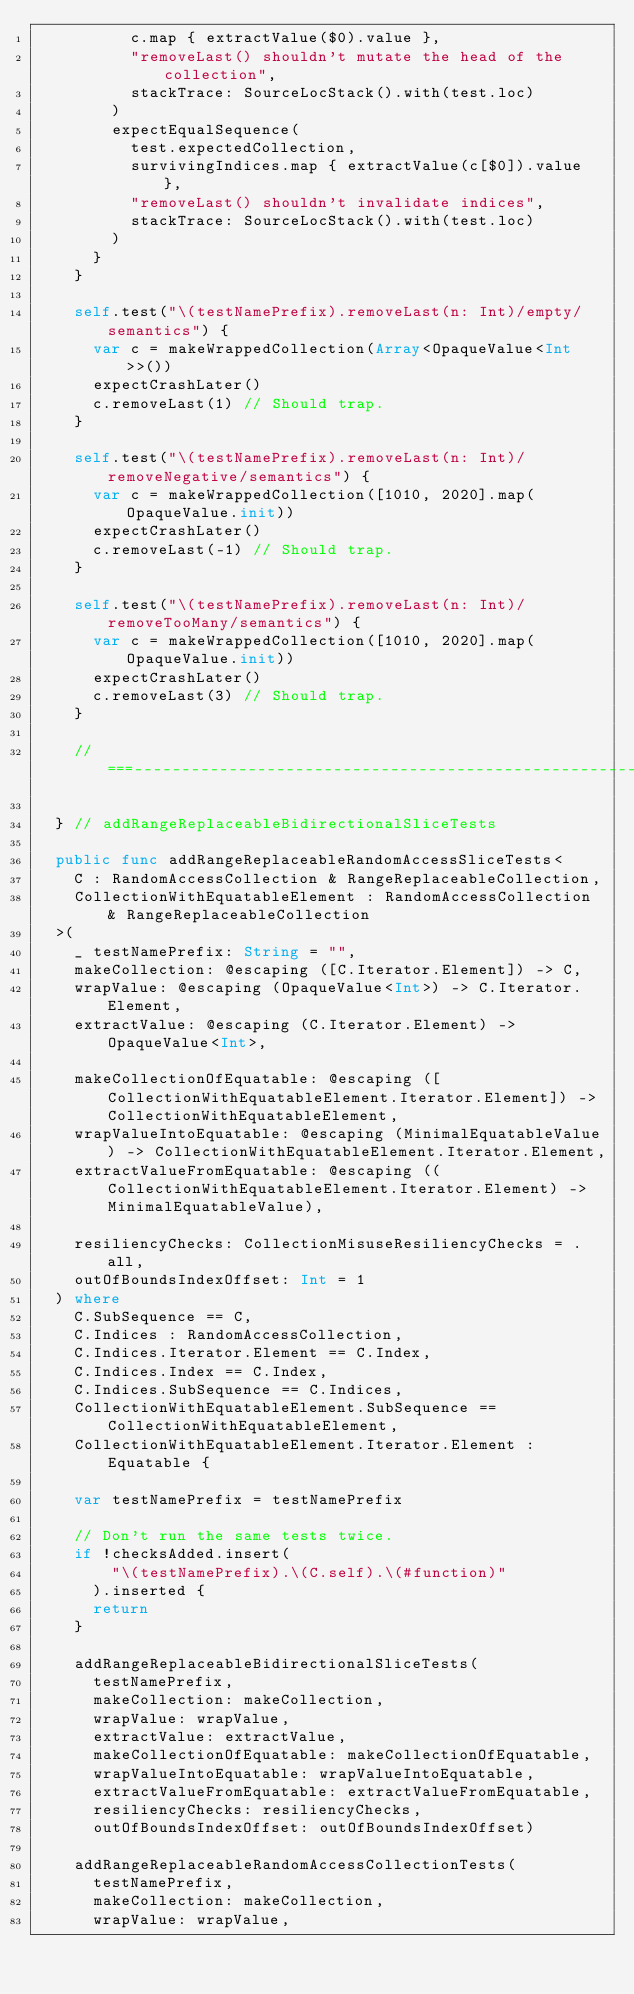<code> <loc_0><loc_0><loc_500><loc_500><_Swift_>          c.map { extractValue($0).value },
          "removeLast() shouldn't mutate the head of the collection",
          stackTrace: SourceLocStack().with(test.loc)
        )
        expectEqualSequence(
          test.expectedCollection,
          survivingIndices.map { extractValue(c[$0]).value },
          "removeLast() shouldn't invalidate indices",
          stackTrace: SourceLocStack().with(test.loc)
        )
      }
    }

    self.test("\(testNamePrefix).removeLast(n: Int)/empty/semantics") {
      var c = makeWrappedCollection(Array<OpaqueValue<Int>>())
      expectCrashLater()
      c.removeLast(1) // Should trap.
    }

    self.test("\(testNamePrefix).removeLast(n: Int)/removeNegative/semantics") {
      var c = makeWrappedCollection([1010, 2020].map(OpaqueValue.init))
      expectCrashLater()
      c.removeLast(-1) // Should trap.
    }

    self.test("\(testNamePrefix).removeLast(n: Int)/removeTooMany/semantics") {
      var c = makeWrappedCollection([1010, 2020].map(OpaqueValue.init))
      expectCrashLater()
      c.removeLast(3) // Should trap.
    }

    //===----------------------------------------------------------------------===//

  } // addRangeReplaceableBidirectionalSliceTests

  public func addRangeReplaceableRandomAccessSliceTests<
    C : RandomAccessCollection & RangeReplaceableCollection,
    CollectionWithEquatableElement : RandomAccessCollection & RangeReplaceableCollection
  >(
    _ testNamePrefix: String = "",
    makeCollection: @escaping ([C.Iterator.Element]) -> C,
    wrapValue: @escaping (OpaqueValue<Int>) -> C.Iterator.Element,
    extractValue: @escaping (C.Iterator.Element) -> OpaqueValue<Int>,

    makeCollectionOfEquatable: @escaping ([CollectionWithEquatableElement.Iterator.Element]) -> CollectionWithEquatableElement,
    wrapValueIntoEquatable: @escaping (MinimalEquatableValue) -> CollectionWithEquatableElement.Iterator.Element,
    extractValueFromEquatable: @escaping ((CollectionWithEquatableElement.Iterator.Element) -> MinimalEquatableValue),

    resiliencyChecks: CollectionMisuseResiliencyChecks = .all,
    outOfBoundsIndexOffset: Int = 1
  ) where
    C.SubSequence == C,
    C.Indices : RandomAccessCollection,
    C.Indices.Iterator.Element == C.Index,
    C.Indices.Index == C.Index,
    C.Indices.SubSequence == C.Indices,
    CollectionWithEquatableElement.SubSequence == CollectionWithEquatableElement,
    CollectionWithEquatableElement.Iterator.Element : Equatable {

    var testNamePrefix = testNamePrefix

    // Don't run the same tests twice.
    if !checksAdded.insert(
        "\(testNamePrefix).\(C.self).\(#function)"
      ).inserted {
      return
    }

    addRangeReplaceableBidirectionalSliceTests(
      testNamePrefix,
      makeCollection: makeCollection,
      wrapValue: wrapValue,
      extractValue: extractValue,
      makeCollectionOfEquatable: makeCollectionOfEquatable,
      wrapValueIntoEquatable: wrapValueIntoEquatable,
      extractValueFromEquatable: extractValueFromEquatable,
      resiliencyChecks: resiliencyChecks,
      outOfBoundsIndexOffset: outOfBoundsIndexOffset)

    addRangeReplaceableRandomAccessCollectionTests(
      testNamePrefix,
      makeCollection: makeCollection,
      wrapValue: wrapValue,</code> 